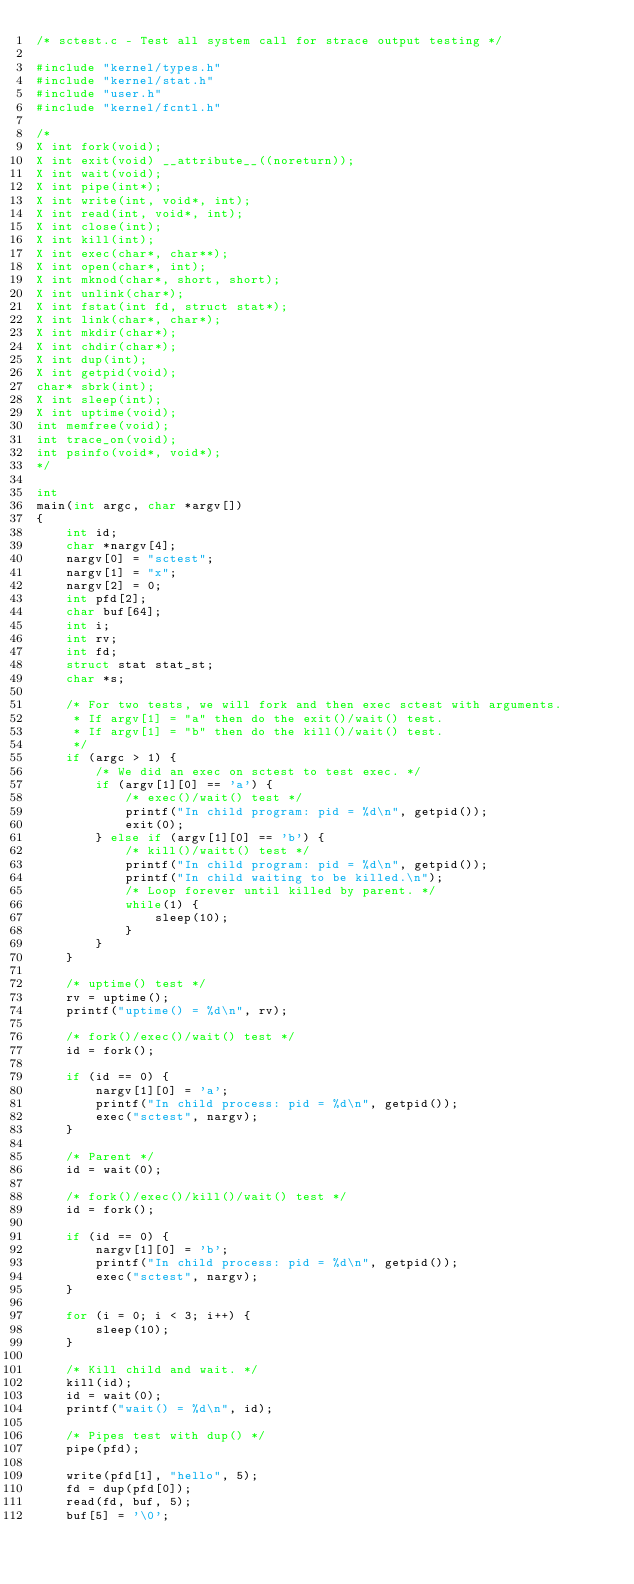<code> <loc_0><loc_0><loc_500><loc_500><_C_>/* sctest.c - Test all system call for strace output testing */

#include "kernel/types.h"
#include "kernel/stat.h"
#include "user.h"
#include "kernel/fcntl.h"

/*
X int fork(void);
X int exit(void) __attribute__((noreturn));
X int wait(void);
X int pipe(int*);
X int write(int, void*, int);
X int read(int, void*, int);
X int close(int);
X int kill(int);
X int exec(char*, char**);
X int open(char*, int);
X int mknod(char*, short, short);
X int unlink(char*);
X int fstat(int fd, struct stat*);
X int link(char*, char*);
X int mkdir(char*);
X int chdir(char*);
X int dup(int);
X int getpid(void);
char* sbrk(int);
X int sleep(int);
X int uptime(void);
int memfree(void);
int trace_on(void);
int psinfo(void*, void*);
*/

int
main(int argc, char *argv[])
{
    int id;
    char *nargv[4];
    nargv[0] = "sctest";
    nargv[1] = "x";
    nargv[2] = 0;
    int pfd[2];
    char buf[64];
    int i;
    int rv;
    int fd;
    struct stat stat_st;
    char *s;

    /* For two tests, we will fork and then exec sctest with arguments.
     * If argv[1] = "a" then do the exit()/wait() test.
     * If argv[1] = "b" then do the kill()/wait() test.
     */
    if (argc > 1) {
        /* We did an exec on sctest to test exec. */
        if (argv[1][0] == 'a') {
            /* exec()/wait() test */
            printf("In child program: pid = %d\n", getpid());
            exit(0);
        } else if (argv[1][0] == 'b') {
            /* kill()/waitt() test */
            printf("In child program: pid = %d\n", getpid());
            printf("In child waiting to be killed.\n");
            /* Loop forever until killed by parent. */
            while(1) {
                sleep(10);
            }
        }
    }

    /* uptime() test */
    rv = uptime();
    printf("uptime() = %d\n", rv);
    
    /* fork()/exec()/wait() test */
    id = fork();

    if (id == 0) {
        nargv[1][0] = 'a';
        printf("In child process: pid = %d\n", getpid());
        exec("sctest", nargv);
    }

    /* Parent */
    id = wait(0);

    /* fork()/exec()/kill()/wait() test */
    id = fork();

    if (id == 0) {
        nargv[1][0] = 'b';
        printf("In child process: pid = %d\n", getpid());
        exec("sctest", nargv);
    }

    for (i = 0; i < 3; i++) {
        sleep(10);
    }

    /* Kill child and wait. */
    kill(id);
    id = wait(0);
    printf("wait() = %d\n", id);

    /* Pipes test with dup() */
    pipe(pfd);

    write(pfd[1], "hello", 5);
    fd = dup(pfd[0]);
    read(fd, buf, 5);
    buf[5] = '\0';</code> 